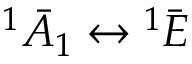Convert formula to latex. <formula><loc_0><loc_0><loc_500><loc_500>^ { 1 } \bar { A } _ { 1 } \leftrightarrow { ^ { 1 } \bar { E } }</formula> 